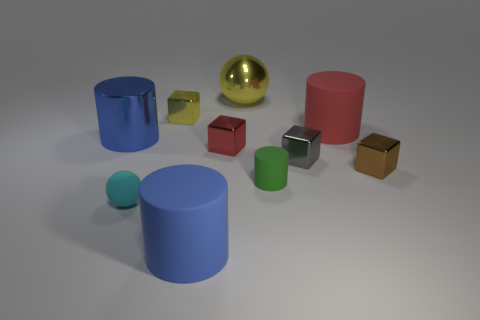Subtract all blue cubes. How many blue cylinders are left? 2 Subtract all red cylinders. How many cylinders are left? 3 Subtract all metallic cylinders. How many cylinders are left? 3 Subtract all blue cubes. Subtract all yellow cylinders. How many cubes are left? 4 Subtract all cubes. How many objects are left? 6 Add 9 small cyan spheres. How many small cyan spheres are left? 10 Add 7 tiny blue shiny cylinders. How many tiny blue shiny cylinders exist? 7 Subtract 2 blue cylinders. How many objects are left? 8 Subtract all tiny green rubber things. Subtract all gray rubber cubes. How many objects are left? 9 